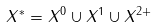<formula> <loc_0><loc_0><loc_500><loc_500>X ^ { * } = X ^ { 0 } \cup X ^ { 1 } \cup X ^ { 2 + }</formula> 